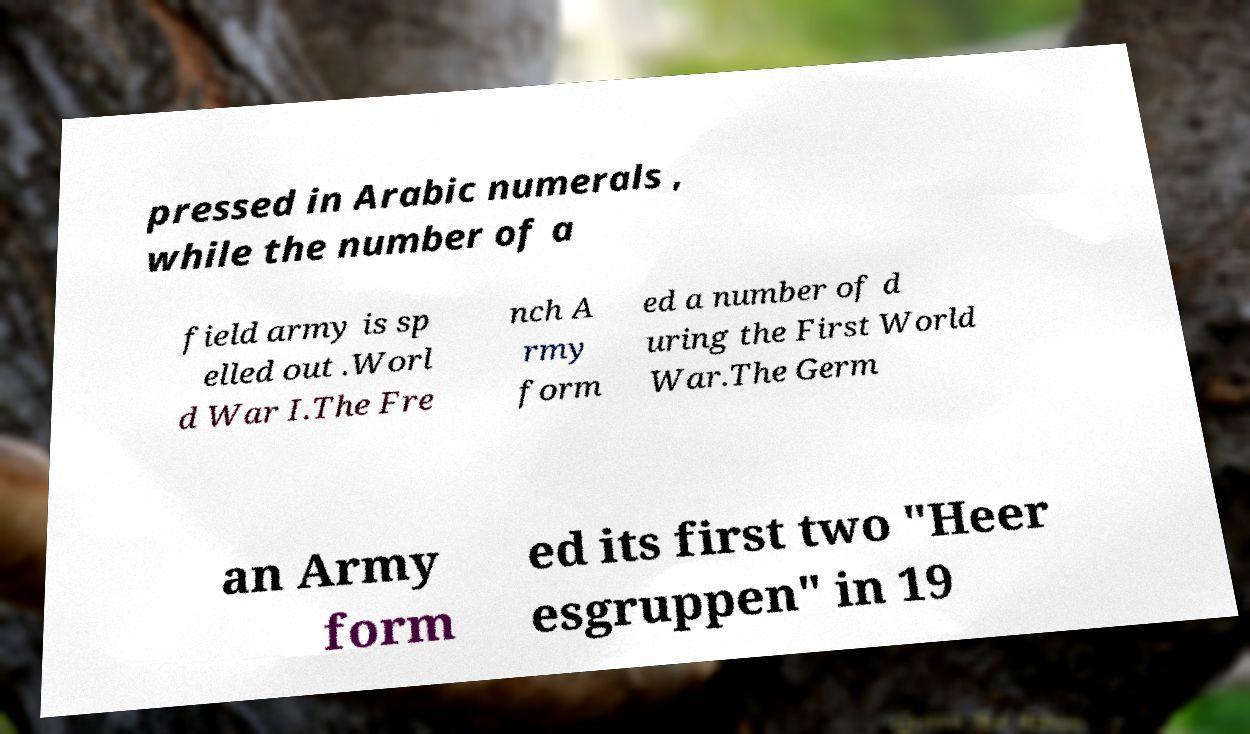Could you extract and type out the text from this image? pressed in Arabic numerals , while the number of a field army is sp elled out .Worl d War I.The Fre nch A rmy form ed a number of d uring the First World War.The Germ an Army form ed its first two "Heer esgruppen" in 19 